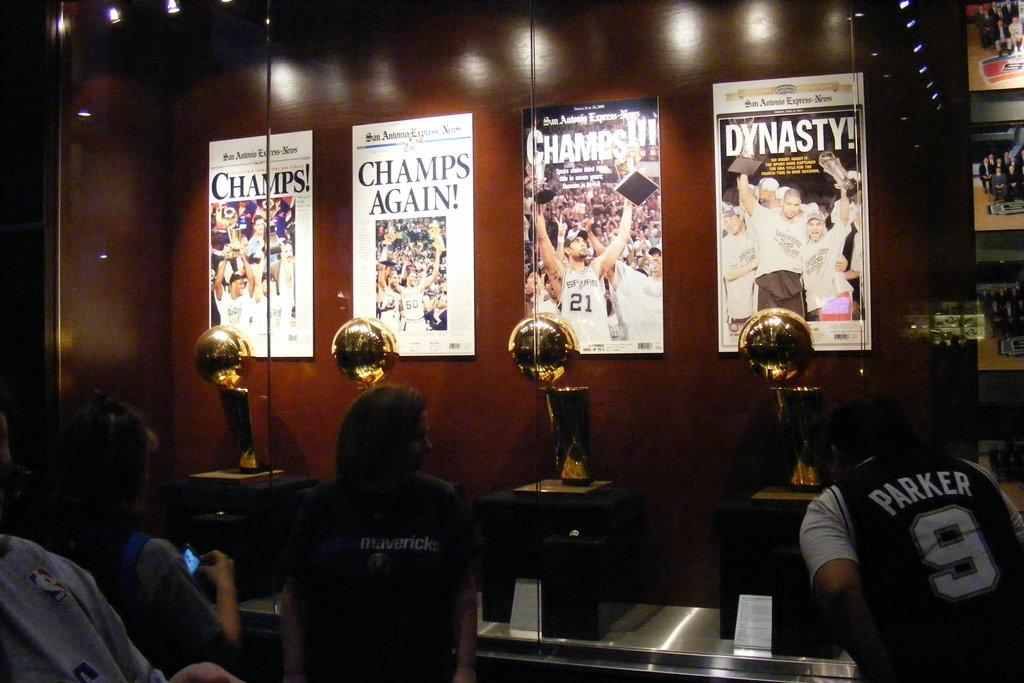<image>
Offer a succinct explanation of the picture presented. In a glass case, there are four basketball trophies, each with posters titled Champs above them. 